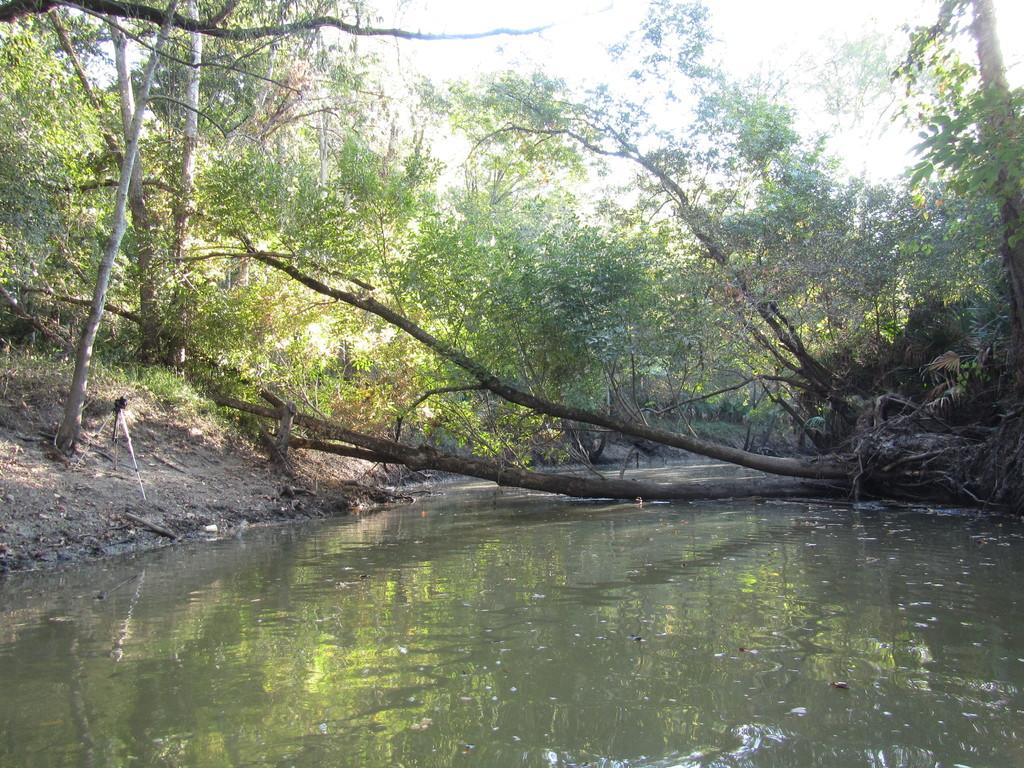What is located at the bottom of the image? There is a pond at the bottom of the image. What can be seen in the middle of the image? There are trees in the middle of the image. What type of wine is being served in the image? There is no wine present in the image; it features a pond and trees. Are there any bears visible in the image? There are no bears present in the image; it features a pond and trees. 